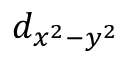Convert formula to latex. <formula><loc_0><loc_0><loc_500><loc_500>d _ { x ^ { 2 } - y ^ { 2 } }</formula> 